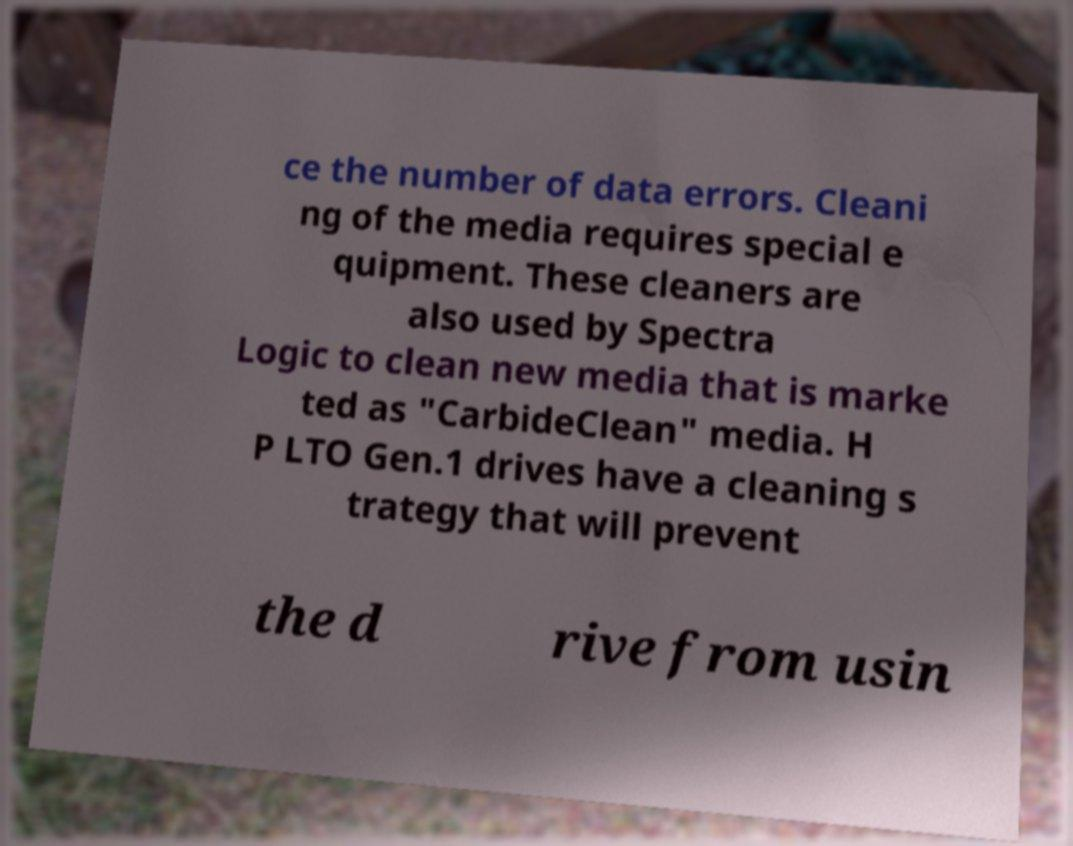Can you accurately transcribe the text from the provided image for me? ce the number of data errors. Cleani ng of the media requires special e quipment. These cleaners are also used by Spectra Logic to clean new media that is marke ted as "CarbideClean" media. H P LTO Gen.1 drives have a cleaning s trategy that will prevent the d rive from usin 